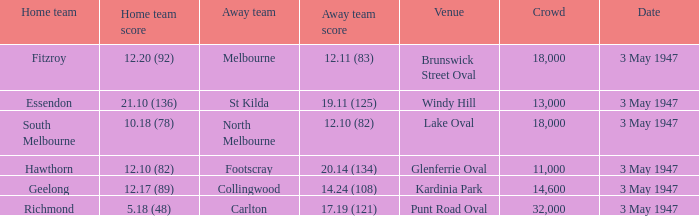In the match where the visiting team scored 17.19 (121), which team was the visitor? Carlton. 